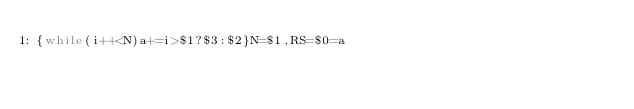Convert code to text. <code><loc_0><loc_0><loc_500><loc_500><_Awk_>{while(i++<N)a+=i>$1?$3:$2}N=$1,RS=$0=a</code> 